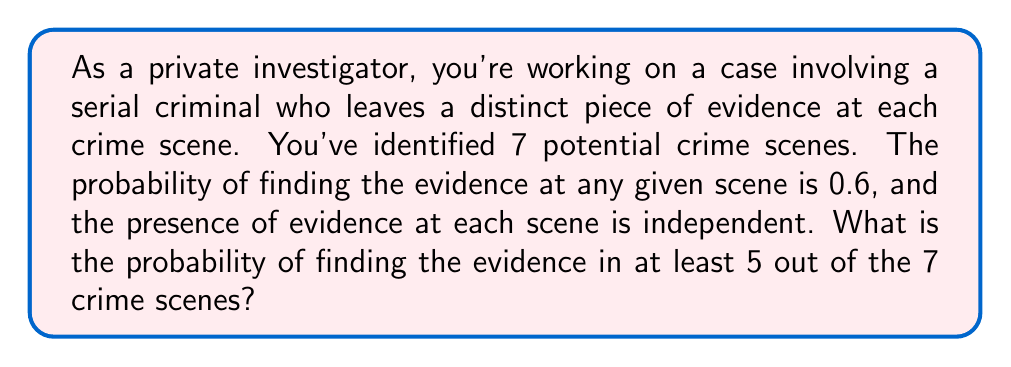Provide a solution to this math problem. To solve this problem, we'll use the binomial probability distribution:

1) Let X be the number of crime scenes where the evidence is found.
   X follows a binomial distribution with n = 7 and p = 0.6

2) We need to find P(X ≥ 5) = P(X = 5) + P(X = 6) + P(X = 7)

3) The probability mass function for a binomial distribution is:
   $$P(X = k) = \binom{n}{k} p^k (1-p)^{n-k}$$

4) Calculate each probability:
   P(X = 5) = $\binom{7}{5} (0.6)^5 (0.4)^2 = 35 \cdot 0.07776 \cdot 0.16 = 0.4362$
   P(X = 6) = $\binom{7}{6} (0.6)^6 (0.4)^1 = 7 \cdot 0.046656 \cdot 0.4 = 0.1306$
   P(X = 7) = $\binom{7}{7} (0.6)^7 (0.4)^0 = 1 \cdot 0.0279936 \cdot 1 = 0.0280$

5) Sum the probabilities:
   P(X ≥ 5) = 0.4362 + 0.1306 + 0.0280 = 0.5948

Therefore, the probability of finding the evidence in at least 5 out of 7 crime scenes is approximately 0.5948 or 59.48%.
Answer: 0.5948 